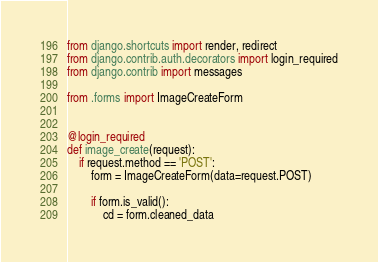Convert code to text. <code><loc_0><loc_0><loc_500><loc_500><_Python_>from django.shortcuts import render, redirect
from django.contrib.auth.decorators import login_required
from django.contrib import messages

from .forms import ImageCreateForm


@login_required
def image_create(request):
    if request.method == 'POST':
        form = ImageCreateForm(data=request.POST)

        if form.is_valid():
            cd = form.cleaned_data</code> 